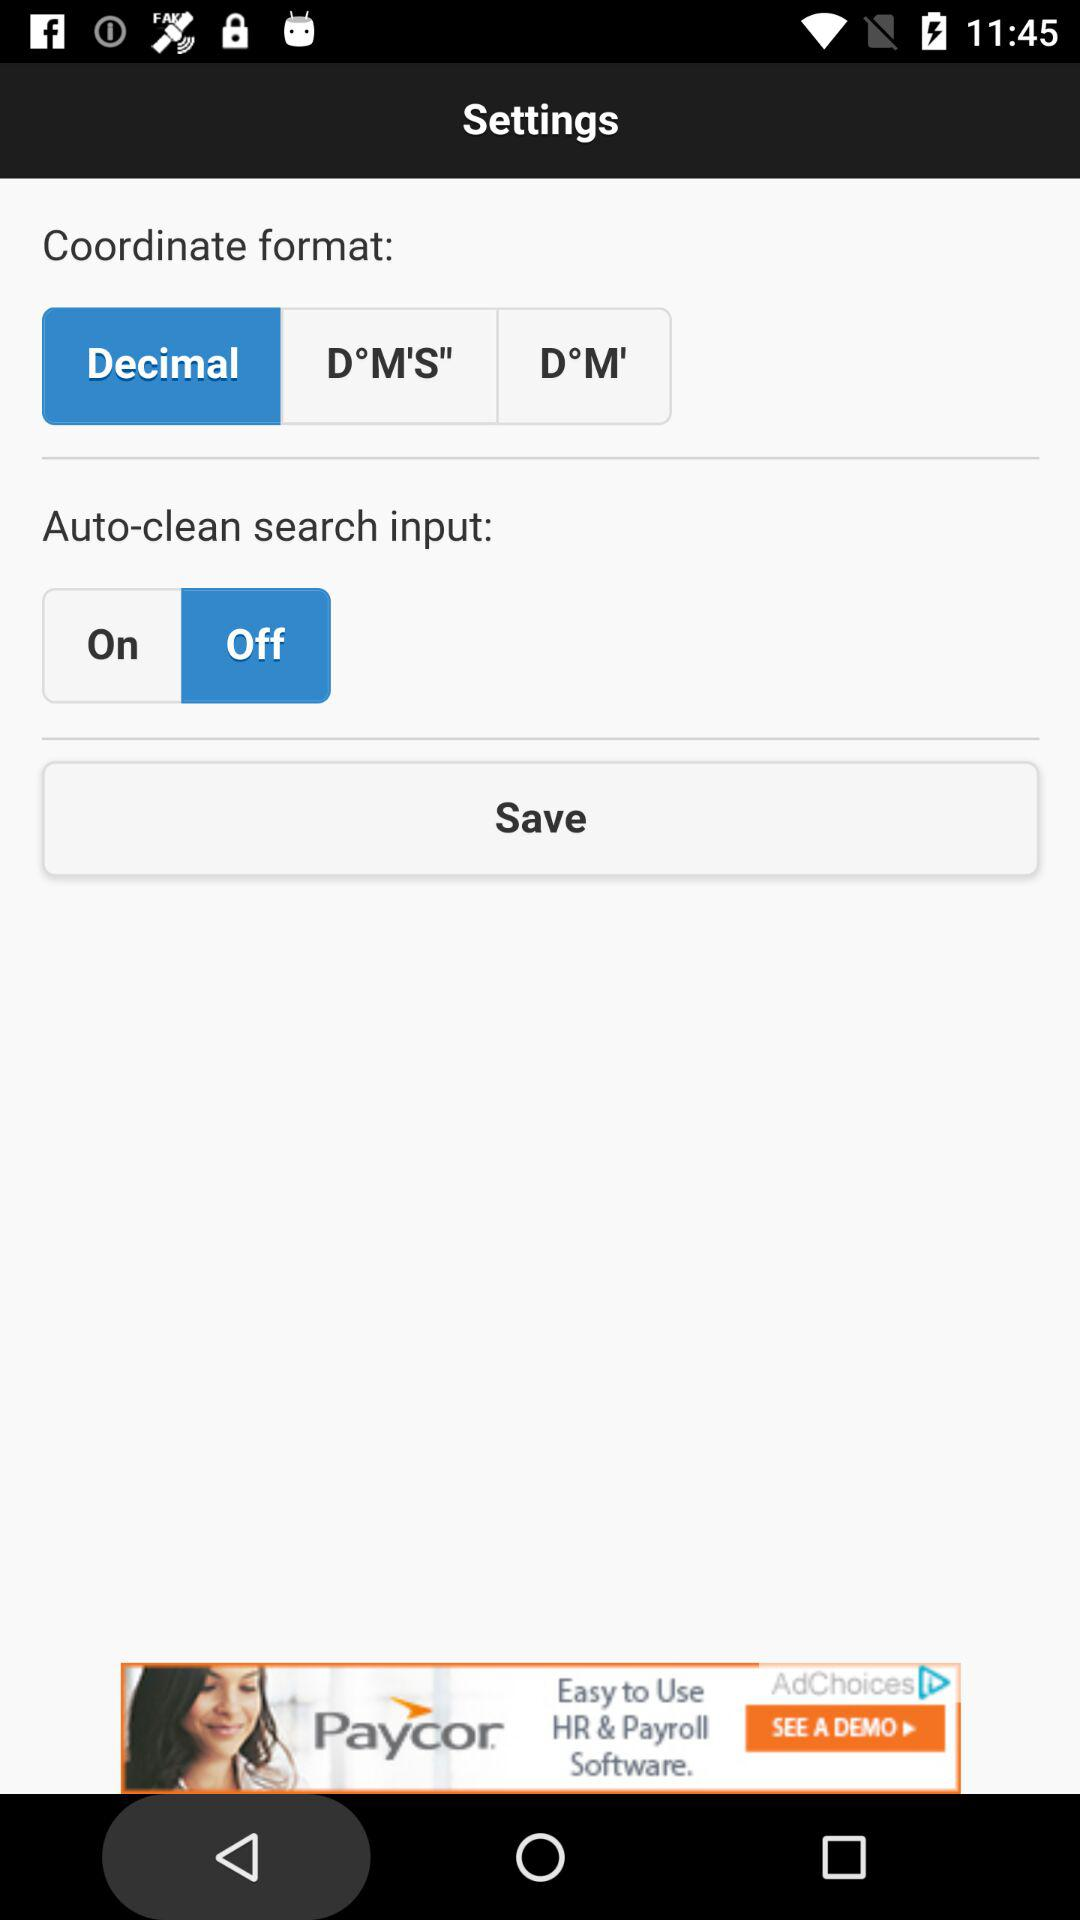When was the last time the settings were saved?
When the provided information is insufficient, respond with <no answer>. <no answer> 